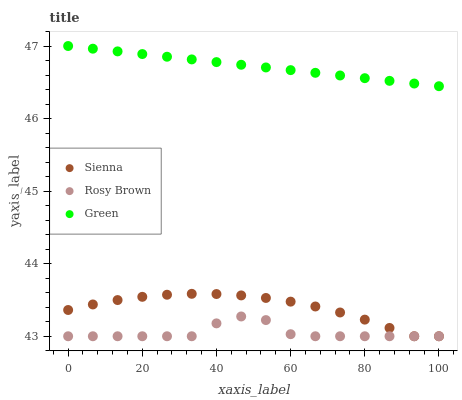Does Rosy Brown have the minimum area under the curve?
Answer yes or no. Yes. Does Green have the maximum area under the curve?
Answer yes or no. Yes. Does Green have the minimum area under the curve?
Answer yes or no. No. Does Rosy Brown have the maximum area under the curve?
Answer yes or no. No. Is Green the smoothest?
Answer yes or no. Yes. Is Rosy Brown the roughest?
Answer yes or no. Yes. Is Rosy Brown the smoothest?
Answer yes or no. No. Is Green the roughest?
Answer yes or no. No. Does Sienna have the lowest value?
Answer yes or no. Yes. Does Green have the lowest value?
Answer yes or no. No. Does Green have the highest value?
Answer yes or no. Yes. Does Rosy Brown have the highest value?
Answer yes or no. No. Is Sienna less than Green?
Answer yes or no. Yes. Is Green greater than Rosy Brown?
Answer yes or no. Yes. Does Rosy Brown intersect Sienna?
Answer yes or no. Yes. Is Rosy Brown less than Sienna?
Answer yes or no. No. Is Rosy Brown greater than Sienna?
Answer yes or no. No. Does Sienna intersect Green?
Answer yes or no. No. 